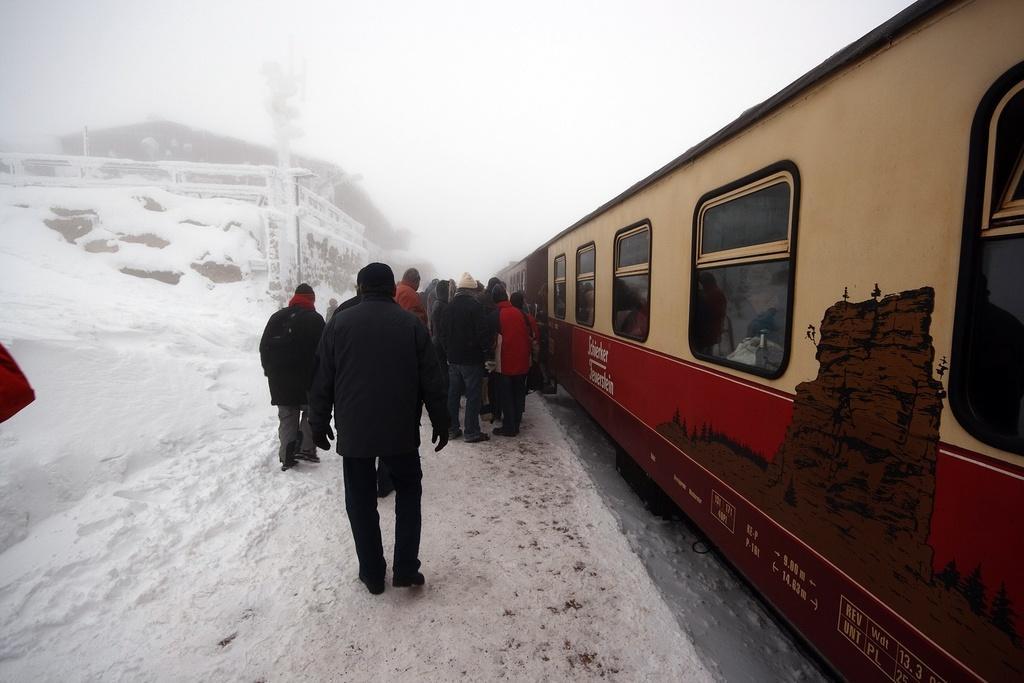In one or two sentences, can you explain what this image depicts? In this picture I can observe some people walking on the platform. There is some snow on the land. On the right side I can observe a train on the railway track. In the background I can observe snowfall. 